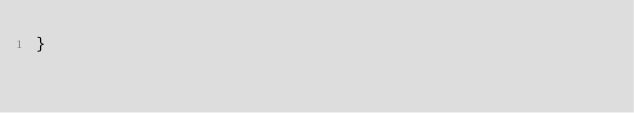<code> <loc_0><loc_0><loc_500><loc_500><_CSS_>}</code> 